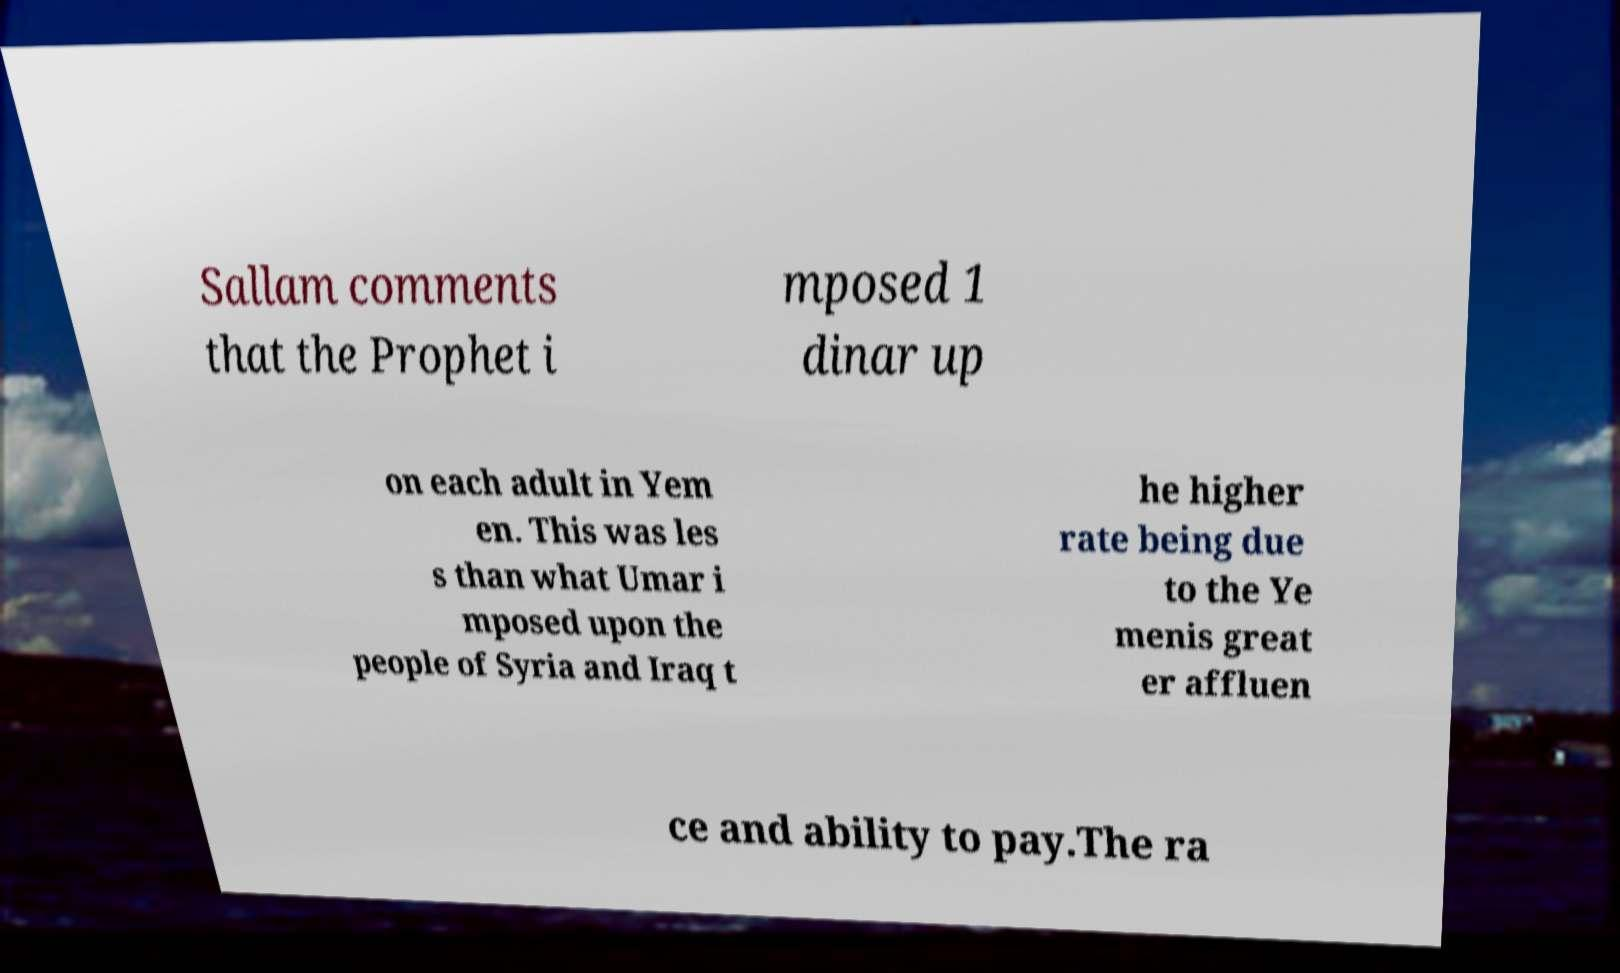Can you accurately transcribe the text from the provided image for me? Sallam comments that the Prophet i mposed 1 dinar up on each adult in Yem en. This was les s than what Umar i mposed upon the people of Syria and Iraq t he higher rate being due to the Ye menis great er affluen ce and ability to pay.The ra 